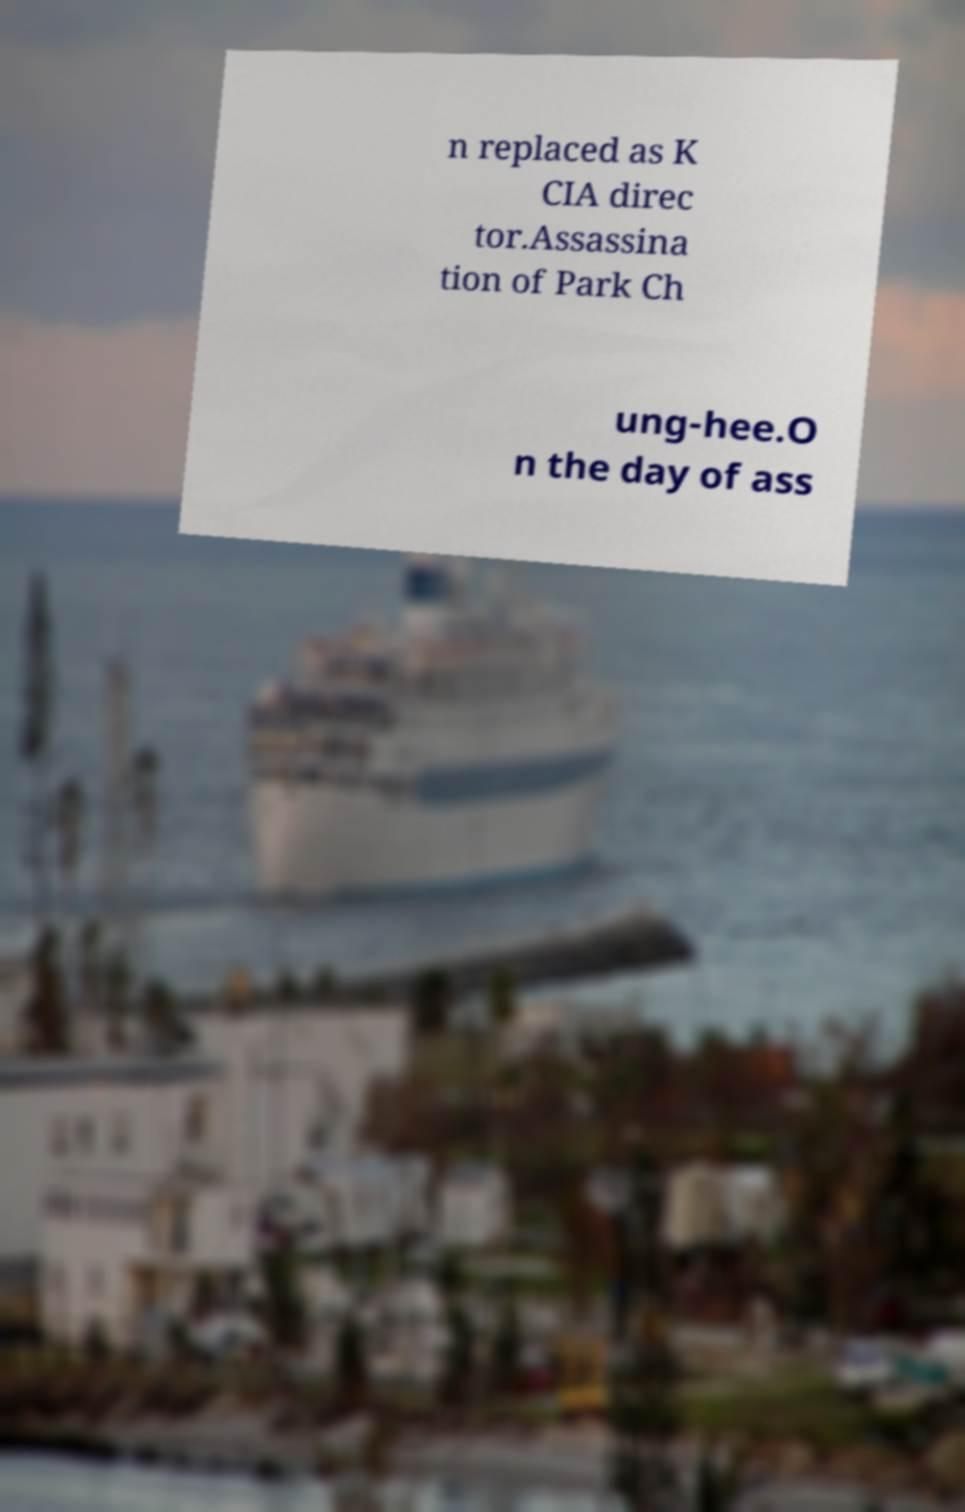Can you read and provide the text displayed in the image?This photo seems to have some interesting text. Can you extract and type it out for me? n replaced as K CIA direc tor.Assassina tion of Park Ch ung-hee.O n the day of ass 